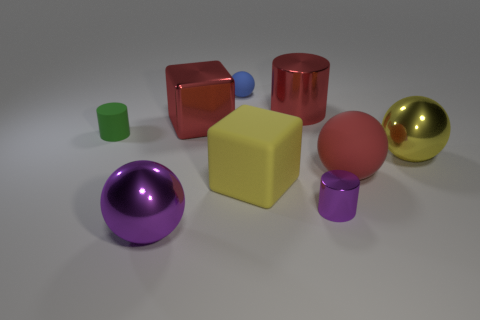Subtract all green matte cylinders. How many cylinders are left? 2 Subtract all yellow balls. How many balls are left? 3 Add 1 large green matte spheres. How many objects exist? 10 Subtract all balls. How many objects are left? 5 Subtract all cyan balls. Subtract all red cubes. How many balls are left? 4 Subtract 0 brown cubes. How many objects are left? 9 Subtract all small purple metallic objects. Subtract all large shiny cylinders. How many objects are left? 7 Add 8 matte spheres. How many matte spheres are left? 10 Add 8 small brown balls. How many small brown balls exist? 8 